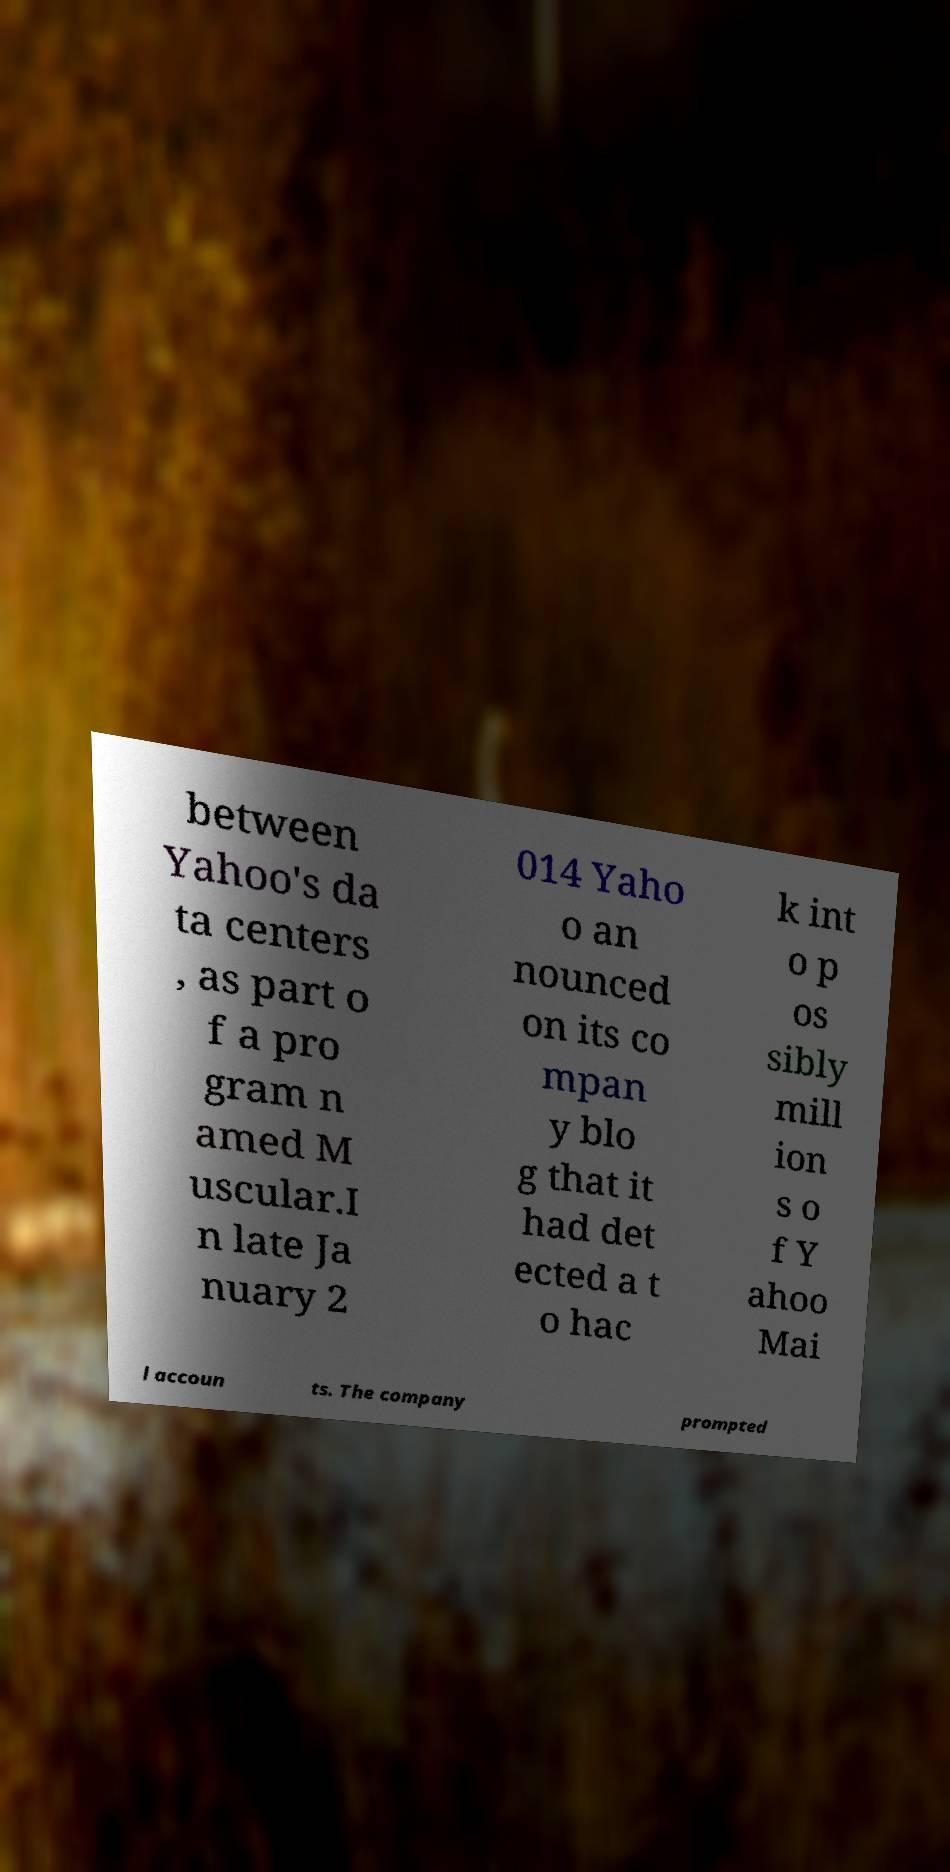Please identify and transcribe the text found in this image. between Yahoo's da ta centers , as part o f a pro gram n amed M uscular.I n late Ja nuary 2 014 Yaho o an nounced on its co mpan y blo g that it had det ected a t o hac k int o p os sibly mill ion s o f Y ahoo Mai l accoun ts. The company prompted 